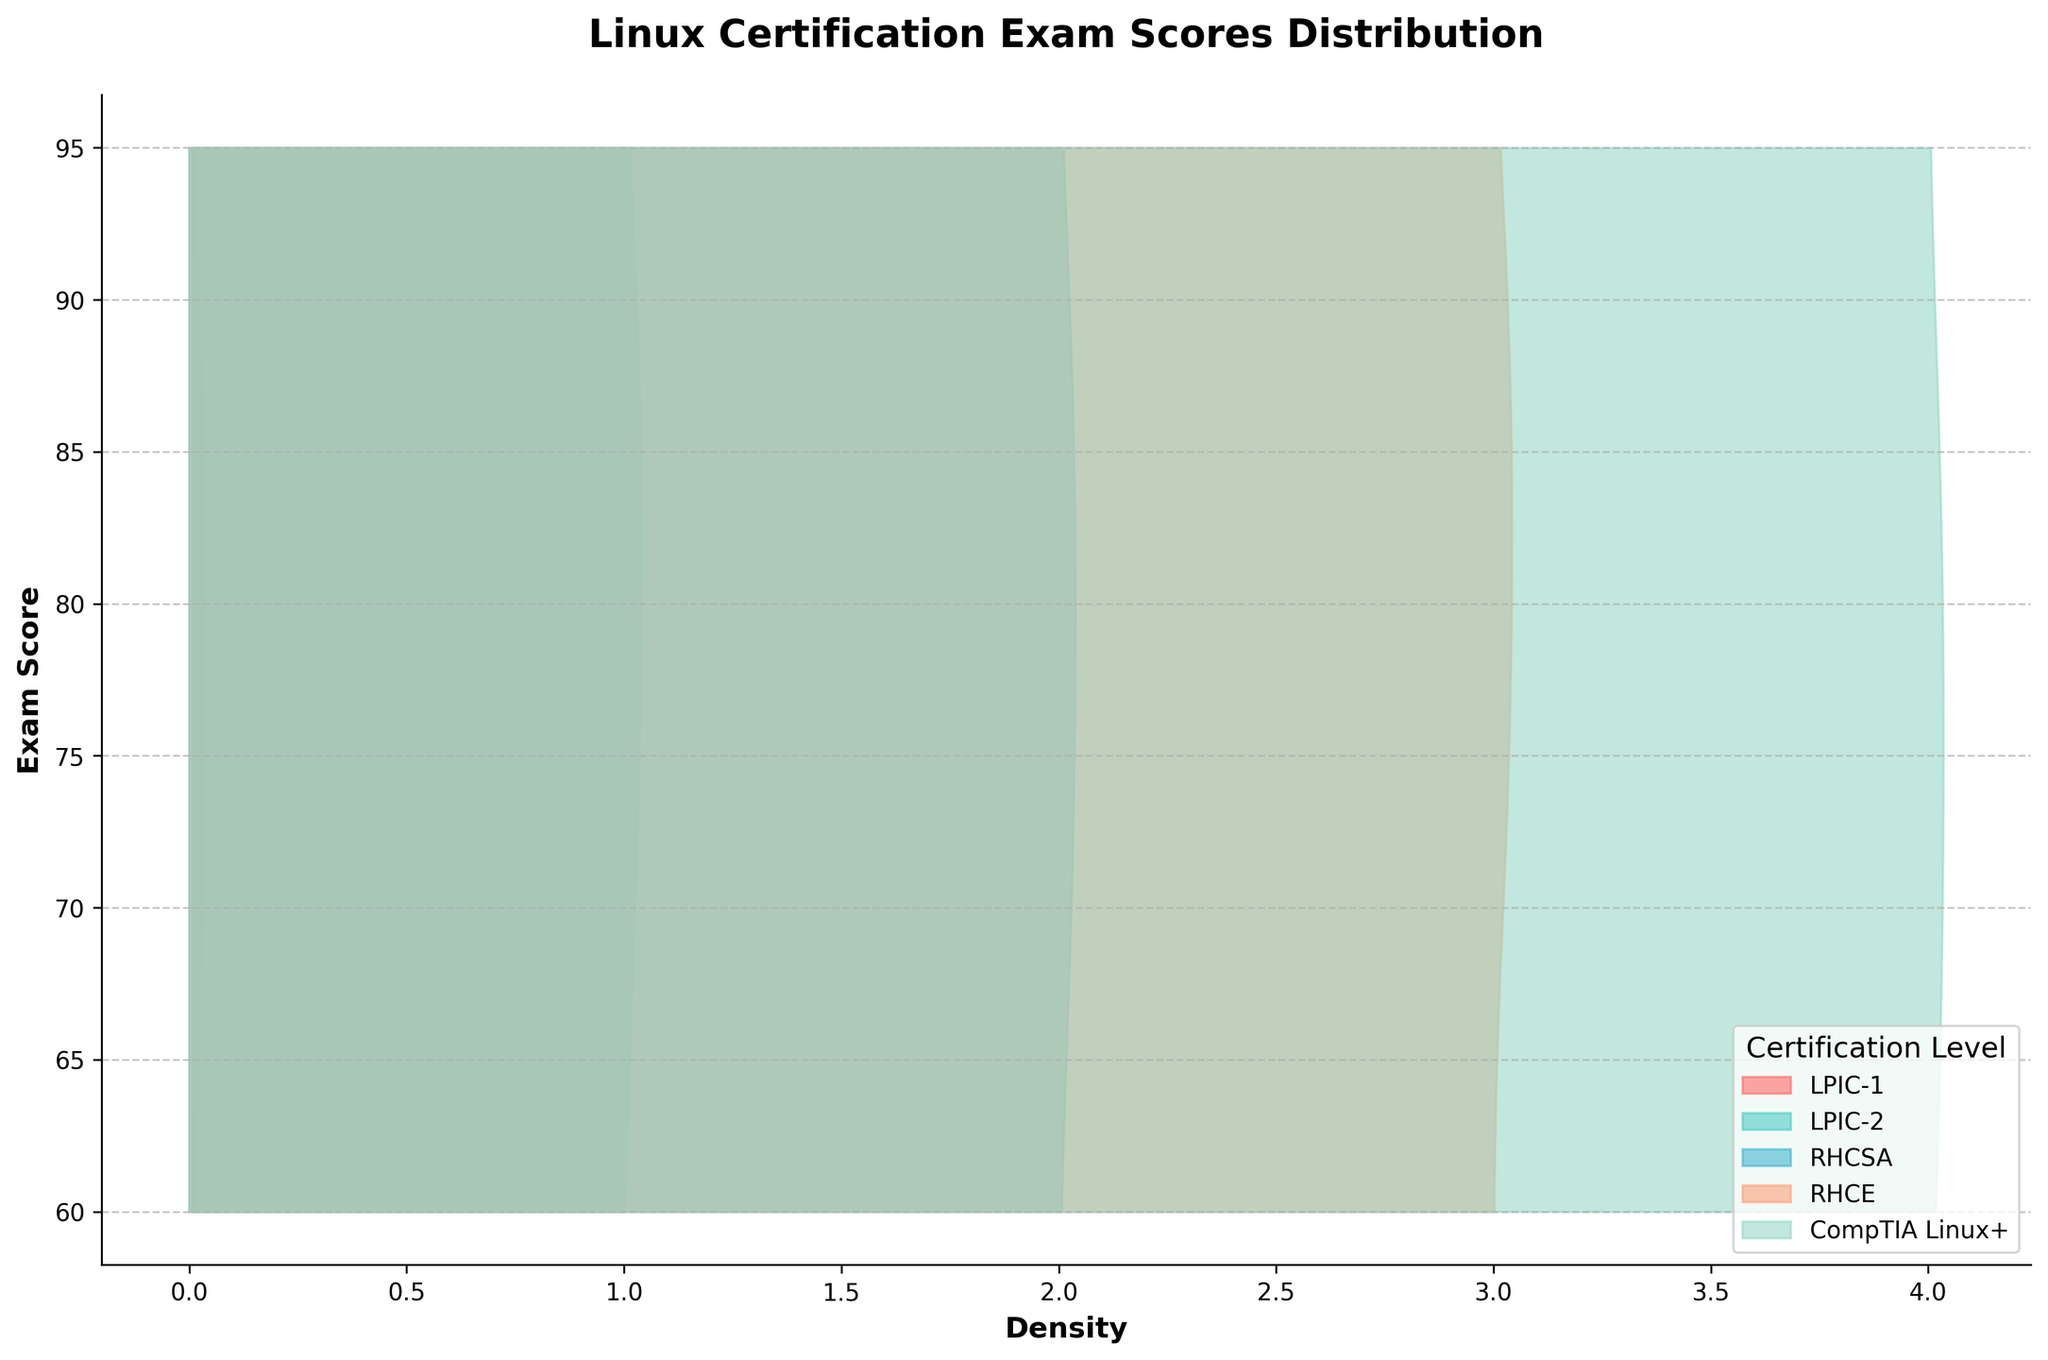what does the title of the plot indicate? The title of the plot is "Linux Certification Exam Scores Distribution," which indicates that the plot shows the distribution of exam scores for different Linux certification levels.
Answer: Linux Certification Exam Scores Distribution what are the y-axis labels and their range in the figure? The y-axis labels represent the exam scores and range from 60 to 95.
Answer: Exam scores; 60-95 how many certification levels are represented in the plot? The figure represents five different certification levels: LPIC-1, LPIC-2, RHCSA, RHCE, and CompTIA Linux+.
Answer: Five which certification level has the highest density at any given score? Examining the plot, it looks like LPIC-1 and RHCE display the highest density peaks at their respective exam scores.
Answer: LPIC-1 and RHCE what is the color associated with RHCSA? Each certification level is represented by a different color, and RHCSA is represented by a light blue or turquoise color.
Answer: Turquoise which certification level has the widest range of exam scores? The plot shows that all certification levels have scores ranging roughly from 60 to 95. However, CompTIA Linux+ has more spread in its density plot, indicating a wider range of exam scores.
Answer: CompTIA Linux+ is the density distribution skewed for any certification level? By looking at the plots, it appears that some distributions have slight skewness. For example, CompTIA Linux+ appears slightly skewed towards the lower end of the score range.
Answer: CompTIA Linux+ how can you identify the certification level that has consistently higher exam scores? By observing the density plot, you can see that the RHCE certification level has a peak and density towards the higher end of the score range consistently.
Answer: RHCE what is the common range where most certification scores fall? Most of the certification scores appear to fall between the 70 and 90 range, based on the overlaps and density peaks in this interval across most certification levels.
Answer: 70-90 which certification level's density changes the most across the score range? CompTIA Linux+'s density appears to change the most across the score range, with noticeable peaks and dips compared to other certifications.
Answer: CompTIA Linux+ 